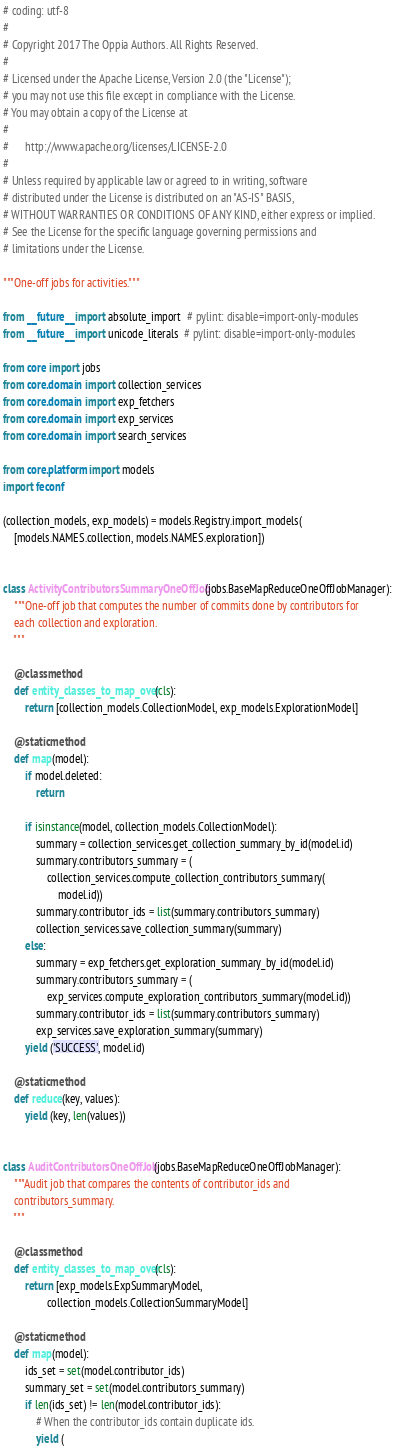Convert code to text. <code><loc_0><loc_0><loc_500><loc_500><_Python_># coding: utf-8
#
# Copyright 2017 The Oppia Authors. All Rights Reserved.
#
# Licensed under the Apache License, Version 2.0 (the "License");
# you may not use this file except in compliance with the License.
# You may obtain a copy of the License at
#
#      http://www.apache.org/licenses/LICENSE-2.0
#
# Unless required by applicable law or agreed to in writing, software
# distributed under the License is distributed on an "AS-IS" BASIS,
# WITHOUT WARRANTIES OR CONDITIONS OF ANY KIND, either express or implied.
# See the License for the specific language governing permissions and
# limitations under the License.

"""One-off jobs for activities."""

from __future__ import absolute_import  # pylint: disable=import-only-modules
from __future__ import unicode_literals  # pylint: disable=import-only-modules

from core import jobs
from core.domain import collection_services
from core.domain import exp_fetchers
from core.domain import exp_services
from core.domain import search_services

from core.platform import models
import feconf

(collection_models, exp_models) = models.Registry.import_models(
    [models.NAMES.collection, models.NAMES.exploration])


class ActivityContributorsSummaryOneOffJob(jobs.BaseMapReduceOneOffJobManager):
    """One-off job that computes the number of commits done by contributors for
    each collection and exploration.
    """

    @classmethod
    def entity_classes_to_map_over(cls):
        return [collection_models.CollectionModel, exp_models.ExplorationModel]

    @staticmethod
    def map(model):
        if model.deleted:
            return

        if isinstance(model, collection_models.CollectionModel):
            summary = collection_services.get_collection_summary_by_id(model.id)
            summary.contributors_summary = (
                collection_services.compute_collection_contributors_summary(
                    model.id))
            summary.contributor_ids = list(summary.contributors_summary)
            collection_services.save_collection_summary(summary)
        else:
            summary = exp_fetchers.get_exploration_summary_by_id(model.id)
            summary.contributors_summary = (
                exp_services.compute_exploration_contributors_summary(model.id))
            summary.contributor_ids = list(summary.contributors_summary)
            exp_services.save_exploration_summary(summary)
        yield ('SUCCESS', model.id)

    @staticmethod
    def reduce(key, values):
        yield (key, len(values))


class AuditContributorsOneOffJob(jobs.BaseMapReduceOneOffJobManager):
    """Audit job that compares the contents of contributor_ids and
    contributors_summary.
    """

    @classmethod
    def entity_classes_to_map_over(cls):
        return [exp_models.ExpSummaryModel,
                collection_models.CollectionSummaryModel]

    @staticmethod
    def map(model):
        ids_set = set(model.contributor_ids)
        summary_set = set(model.contributors_summary)
        if len(ids_set) != len(model.contributor_ids):
            # When the contributor_ids contain duplicate ids.
            yield (</code> 